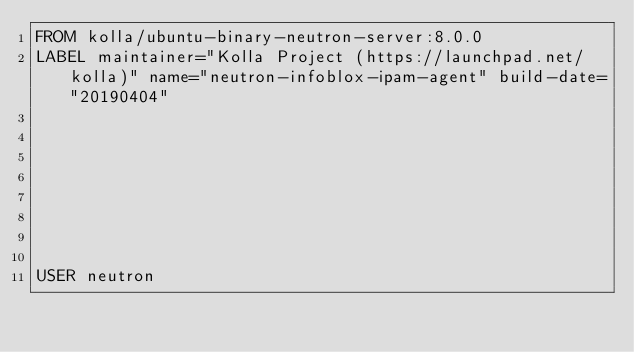Convert code to text. <code><loc_0><loc_0><loc_500><loc_500><_Dockerfile_>FROM kolla/ubuntu-binary-neutron-server:8.0.0
LABEL maintainer="Kolla Project (https://launchpad.net/kolla)" name="neutron-infoblox-ipam-agent" build-date="20190404"








USER neutron</code> 